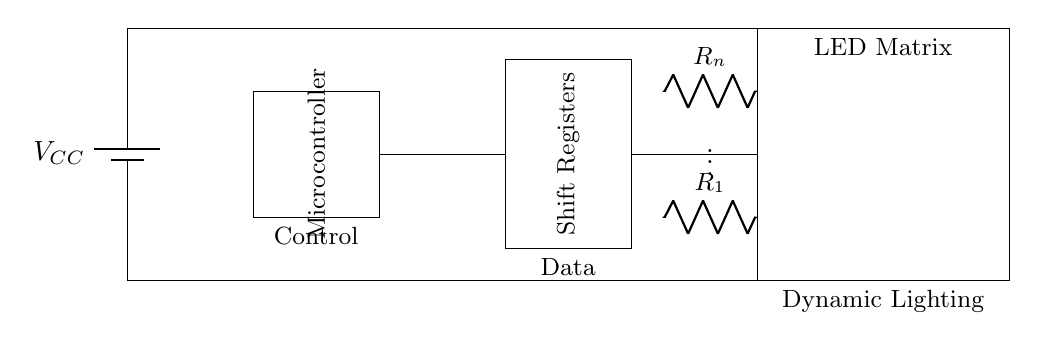What is the main component that controls the LED matrix? The microcontroller is the main component responsible for controlling the operation and lighting of the LED matrix, as indicated in the circuit diagram.
Answer: microcontroller How many shift registers are present in the circuit? There is one shift register unit shown in the diagram, which is depicted as a single rectangle labeled 'Shift Registers'.
Answer: one What is the purpose of the current limiting resistors? The current limiting resistors (labeled R1 to Rn) are used to control the amount of current flowing through each LED in the matrix, preventing them from burning out due to excess current.
Answer: current limiting What is the voltage source labeled in the circuit? The voltage source is labeled VCC, providing power to the entire circuit. This is a common labeling in electronics, indicating the power supply.
Answer: VCC How does the data flow in this circuit? Data flows from the microcontroller to the shift registers, and then from the shift registers to the LED matrix, as shown by the connections between these components.
Answer: microcontroller to shift registers to LED matrix Which configuration could the matrix create in terms of lighting? The LED matrix can create dynamic lighting effects by controlling the individual LEDs based on the signals received from the microcontroller through the shift registers.
Answer: dynamic lighting effects What is inferred from the placement of the LED matrix in the circuit? The LED matrix is placed at the end of the data flow, indicating that it is the final output device that displays the lighting effects driven by the microcontroller and shift registers.
Answer: output device 